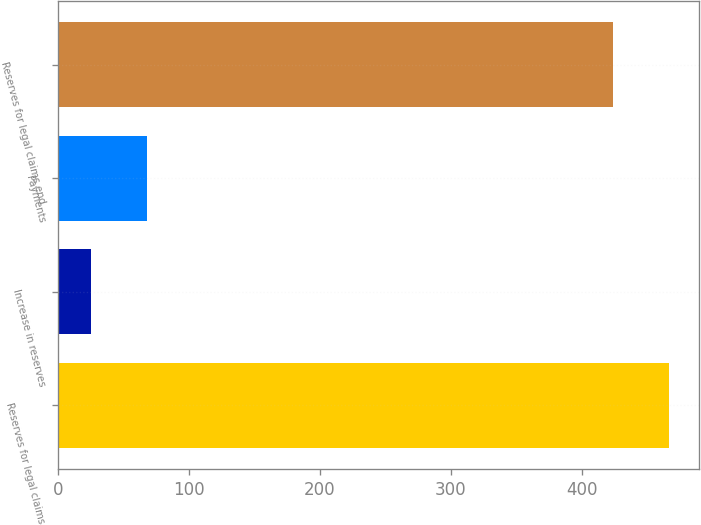Convert chart. <chart><loc_0><loc_0><loc_500><loc_500><bar_chart><fcel>Reserves for legal claims<fcel>Increase in reserves<fcel>Payments<fcel>Reserves for legal claims end<nl><fcel>466.06<fcel>25.4<fcel>67.96<fcel>423.5<nl></chart> 